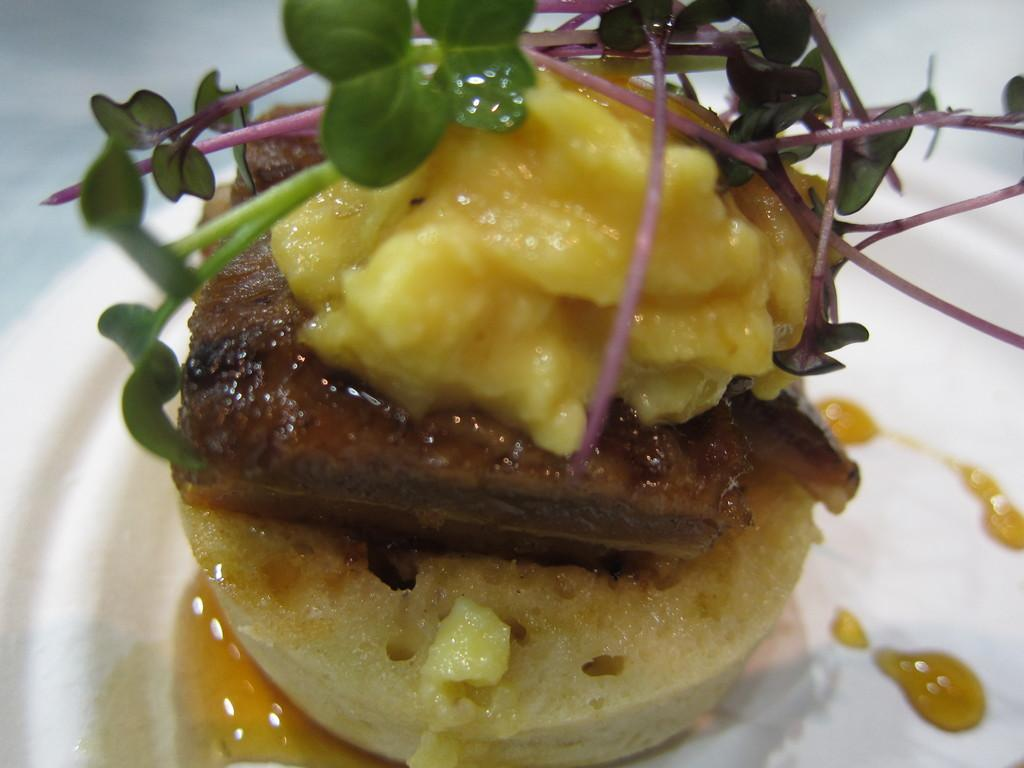What type of food can be seen in the image? The food in the image has yellow and brown colors. How is the food arranged in the image? The food is in a plate. What color is the plate? The plate is white. What type of border is present around the food in the image? There is no border present around the food in the image. Can you see a spade being used to serve the food in the image? There is no spade visible in the image. 